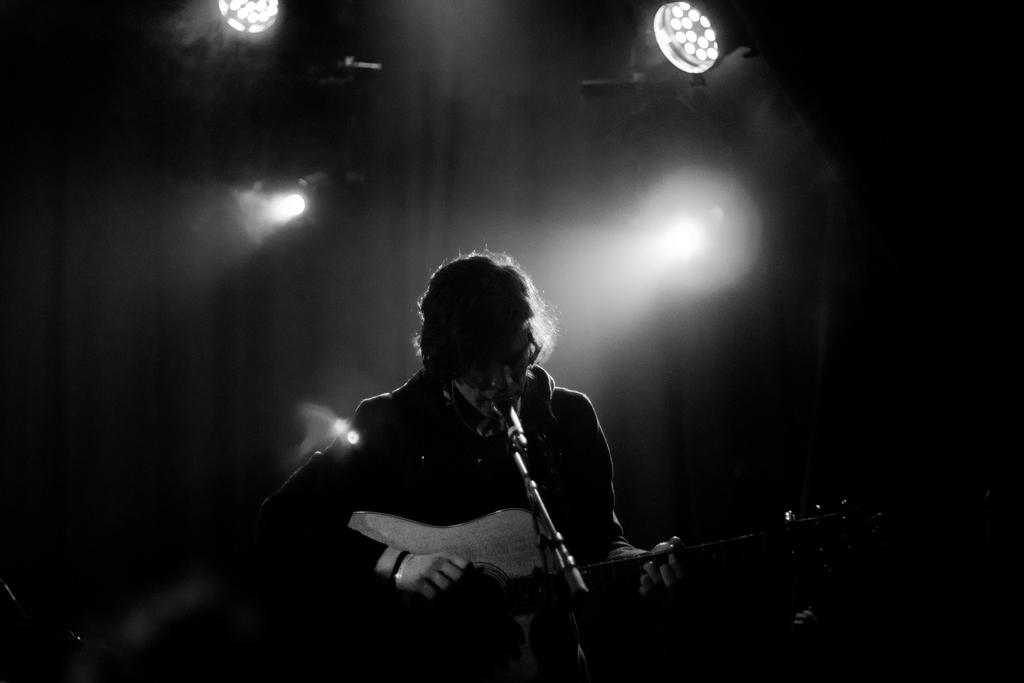What is the man in the image doing? The man is playing the guitar and singing on a mic. What instrument is the man holding in the image? The man is holding a guitar in the image. What can be seen in the background of the image? There are lights in the background of the image. How would you describe the lighting in the image? The setting is dark in the image. What type of road is visible in the image? There is no road visible in the image. What emotion is the man feeling while singing on the mic? The image does not provide information about the man's emotions, so it cannot be determined from the image. 